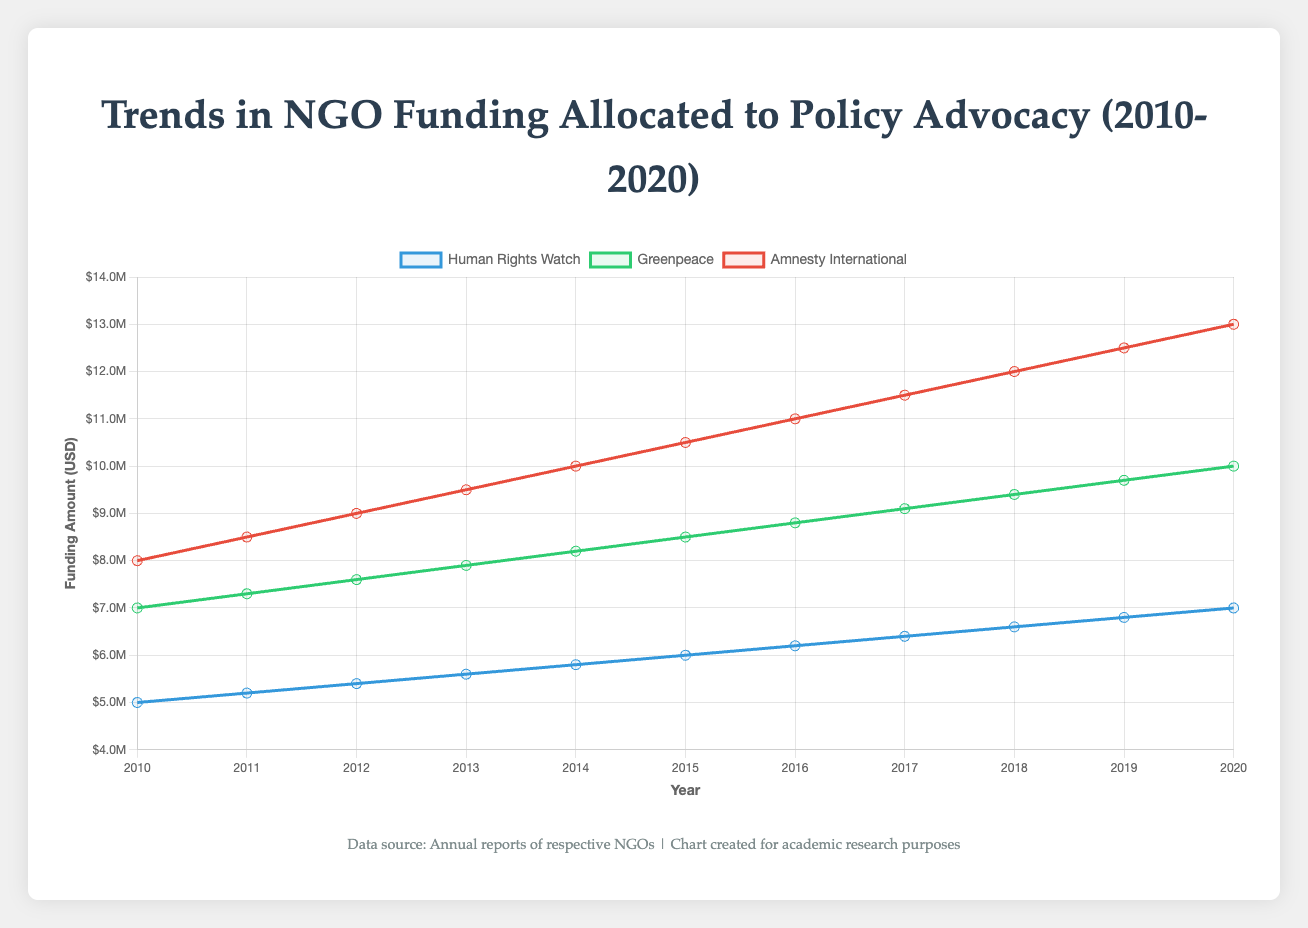What is the trend of funding for "Greenpeace" over the years from 2010 to 2020? To answer this question, look at the line representing "Greenpeace," which is green. Note how the values change from 2010 to 2020. The trend shows an overall increase from $7,000,000 in 2010 to $10,000,000 in 2020.
Answer: Increasing In which year did "Amnesty International" receive the most funding? Referring to the red line representing "Amnesty International," observe the points from 2010 to 2020. The highest point is in 2020 with a funding amount of $13,000,000.
Answer: 2020 Compare the funding amount for "Human Rights Watch" and "Greenpeace" in 2015. Which organization received more funding? Find the year 2015 on the x-axis and compare the values of the blue line (Human Rights Watch) and the green line (Greenpeace). Human Rights Watch received $6,000,000, whereas Greenpeace received $8,500,000. Therefore, Greenpeace received more funding in 2015.
Answer: Greenpeace What is the total funding amount for "Amnesty International" over the years 2010, 2011, and 2012? To find this, sum the values for "Amnesty International" (red line) for 2010 ($8,000,000), 2011 ($8,500,000), and 2012 ($9,000,000): $8,000,000 + $8,500,000 + $9,000,000 = $25,500,000.
Answer: $25,500,000 Which organization had the smallest increase in funding from 2010 to 2020? To determine this, calculate the difference in funding for each organization from 2010 to 2020. Human Rights Watch increased from $5,000,000 to $7,000,000 ($2,000,000 increase), Greenpeace from $7,000,000 to $10,000,000 ($3,000,000 increase), and Amnesty International from $8,000,000 to $13,000,000 ($5,000,000 increase). Human Rights Watch had the smallest increase.
Answer: Human Rights Watch Calculate the average funding for "Greenpeace" over the years 2015 to 2020. The years 2015 to 2020 have the following funding amounts for Greenpeace (green line): $8,500,000, $8,800,000, $9,100,000, $9,400,000, $9,700,000, $10,000,000. Sum these values and divide by the number of years: ($8,500,000 + $8,800,000 + $9,100,000 + $9,400,000 + $9,700,000 + $10,000,000) / 6 ≈ $9,250,000.
Answer: $9,250,000 Which organization's funding shows the steepest increase between two consecutive years, and during which years does this occur? Evaluate the difference between consecutive years for each organization. Amnesty International (red line) shows the largest jump from 2011 ($8,500,000) to 2012 ($9,000,000), which is a $500,000 increase, and this pattern is consistent between 2018 to 2019 and 2019 to 2020 with consistent $500,000 jumps.
Answer: Amnesty International, 2011-2012 What is the combined funding amount for all three NGOs in the year 2017? Sum the funding amounts for all three NGOs for 2017: Human Rights Watch ($6,400,000), Greenpeace ($9,100,000), and Amnesty International ($11,500,000). The combined funding is $6,400,000 + $9,100,000 + $11,500,000 = $27,000,000.
Answer: $27,000,000 Does "Human Rights Watch" ever surpass "Greenpeace" in funding during the period from 2010 to 2020? Observe the blue and green lines from 2010 to 2020. At no point does the blue line (Human Rights Watch) surpass the green line (Greenpeace).
Answer: No 